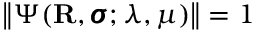<formula> <loc_0><loc_0><loc_500><loc_500>\left \| \Psi ( R , \pm b { \sigma } ; \lambda , \mu ) \right \| = 1</formula> 